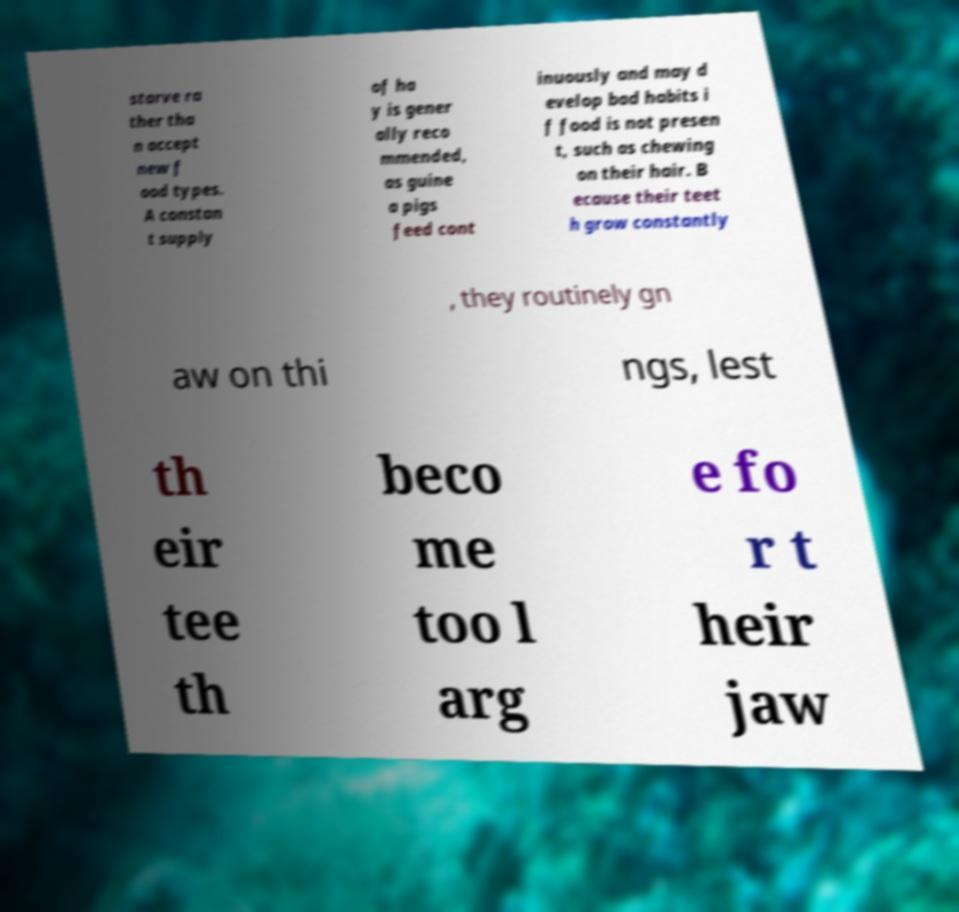Could you assist in decoding the text presented in this image and type it out clearly? starve ra ther tha n accept new f ood types. A constan t supply of ha y is gener ally reco mmended, as guine a pigs feed cont inuously and may d evelop bad habits i f food is not presen t, such as chewing on their hair. B ecause their teet h grow constantly , they routinely gn aw on thi ngs, lest th eir tee th beco me too l arg e fo r t heir jaw 